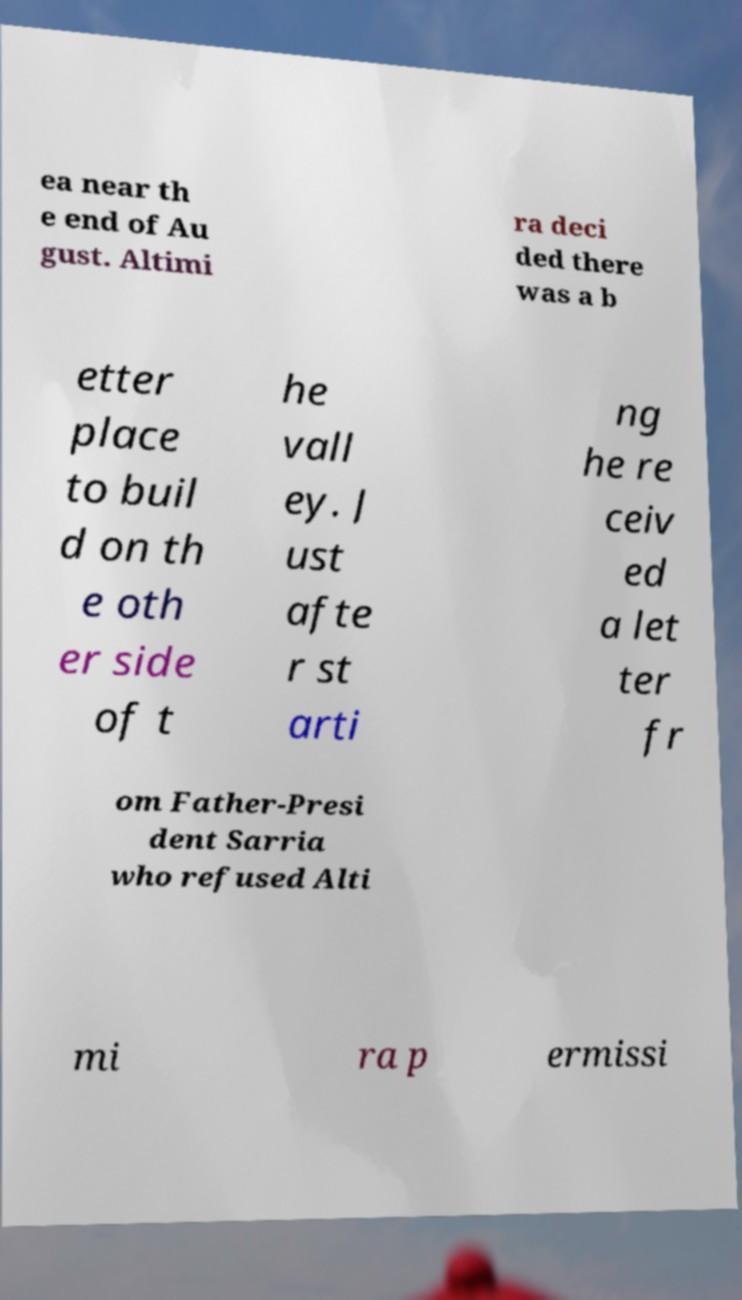Can you accurately transcribe the text from the provided image for me? ea near th e end of Au gust. Altimi ra deci ded there was a b etter place to buil d on th e oth er side of t he vall ey. J ust afte r st arti ng he re ceiv ed a let ter fr om Father-Presi dent Sarria who refused Alti mi ra p ermissi 